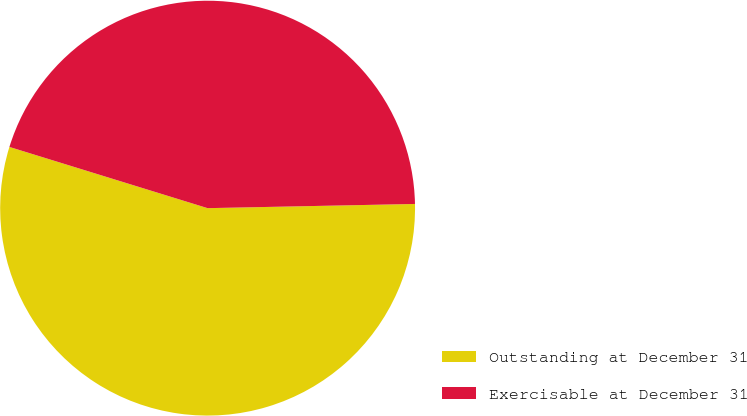Convert chart. <chart><loc_0><loc_0><loc_500><loc_500><pie_chart><fcel>Outstanding at December 31<fcel>Exercisable at December 31<nl><fcel>55.09%<fcel>44.91%<nl></chart> 